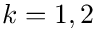<formula> <loc_0><loc_0><loc_500><loc_500>k = 1 , 2</formula> 